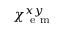<formula> <loc_0><loc_0><loc_500><loc_500>\chi _ { e m } ^ { x y }</formula> 